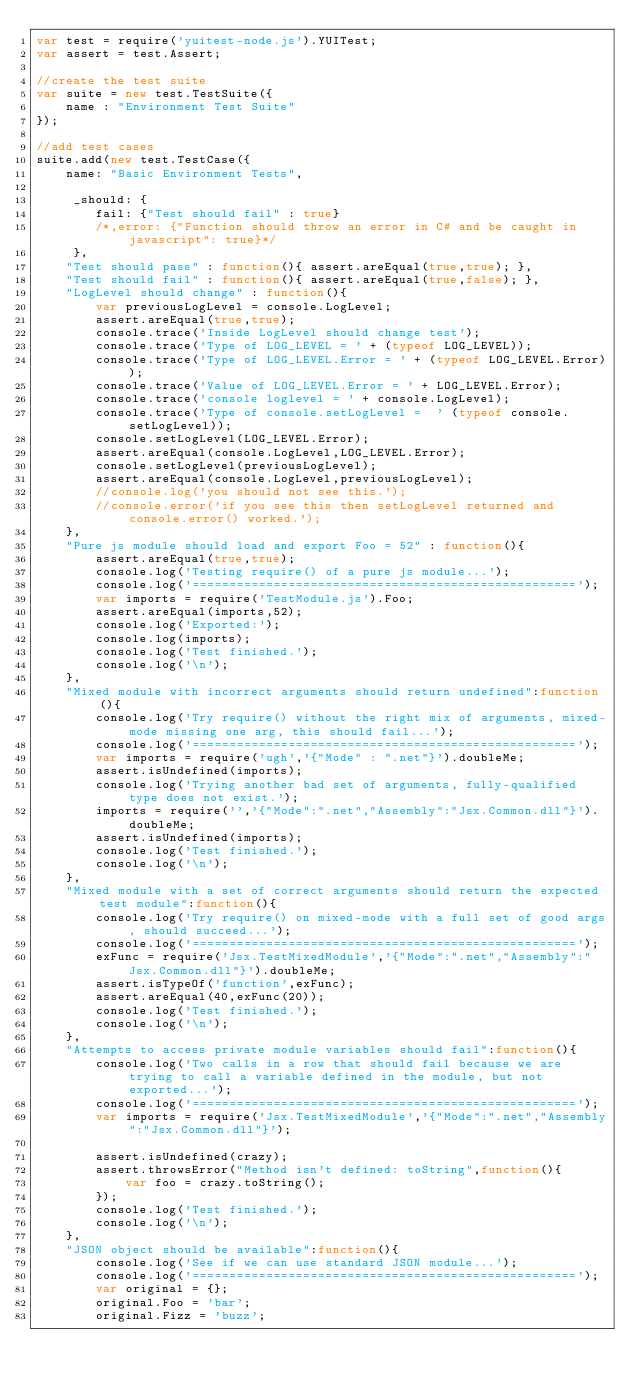<code> <loc_0><loc_0><loc_500><loc_500><_JavaScript_>var test = require('yuitest-node.js').YUITest;
var assert = test.Assert;

//create the test suite
var suite = new test.TestSuite({
	name : "Environment Test Suite"
});

//add test cases
suite.add(new test.TestCase({
    name: "Basic Environment Tests",
  
     _should: {
     	fail: {"Test should fail" : true}
     	/*,error: {"Function should throw an error in C# and be caught in javascript": true}*/
     },
    "Test should pass" : function(){ assert.areEqual(true,true); },
    "Test should fail" : function(){ assert.areEqual(true,false); },
    "LogLevel should change" : function(){ 
    	var previousLogLevel = console.LogLevel;
    	assert.areEqual(true,true);
    	console.trace('Inside LogLevel should change test');
    	console.trace('Type of LOG_LEVEL = ' + (typeof LOG_LEVEL));
    	console.trace('Type of LOG_LEVEL.Error = ' + (typeof LOG_LEVEL.Error));
    	console.trace('Value of LOG_LEVEL.Error = ' + LOG_LEVEL.Error);
    	console.trace('console loglevel = ' + console.LogLevel);
    	console.trace('Type of console.setLogLevel =  ' (typeof console.setLogLevel));
    	console.setLogLevel(LOG_LEVEL.Error);
    	assert.areEqual(console.LogLevel,LOG_LEVEL.Error);
    	console.setLogLevel(previousLogLevel);
    	assert.areEqual(console.LogLevel,previousLogLevel);
    	//console.log('you should not see this.');
    	//console.error('if you see this then setLogLevel returned and console.error() worked.');
    },
    "Pure js module should load and export Foo = 52" : function(){
    	assert.areEqual(true,true);
    	console.log('Testing require() of a pure js module...');
		console.log('====================================================');
    	var imports = require('TestModule.js').Foo;
    	assert.areEqual(imports,52);
		console.log('Exported:');
		console.log(imports);
		console.log('Test finished.');
		console.log('\n');
    },
    "Mixed module with incorrect arguments should return undefined":function(){
    	console.log('Try require() without the right mix of arguments, mixed-mode missing one arg, this should fail...');
		console.log('====================================================');
		var imports = require('ugh','{"Mode" : ".net"}').doubleMe;
		assert.isUndefined(imports);
		console.log('Trying another bad set of arguments, fully-qualified type does not exist.');
		imports = require('','{"Mode":".net","Assembly":"Jsx.Common.dll"}').doubleMe;
		assert.isUndefined(imports);
		console.log('Test finished.');
		console.log('\n');
    },
    "Mixed module with a set of correct arguments should return the expected test module":function(){
    	console.log('Try require() on mixed-mode with a full set of good args, should succeed...');
		console.log('====================================================');
		exFunc = require('Jsx.TestMixedModule','{"Mode":".net","Assembly":"Jsx.Common.dll"}').doubleMe;
		assert.isTypeOf('function',exFunc);
		assert.areEqual(40,exFunc(20));
		console.log('Test finished.');
		console.log('\n');
    },
    "Attempts to access private module variables should fail":function(){
    	console.log('Two calls in a row that should fail because we are trying to call a variable defined in the module, but not exported...');
    	console.log('====================================================');
		var imports = require('Jsx.TestMixedModule','{"Mode":".net","Assembly":"Jsx.Common.dll"}');
		
		assert.isUndefined(crazy);
		assert.throwsError("Method isn't defined: toString",function(){
			var foo = crazy.toString();
		});
		console.log('Test finished.');
		console.log('\n');
    },
    "JSON object should be available":function(){
    	console.log('See if we can use standard JSON module...');
		console.log('====================================================');
		var original = {};
		original.Foo = 'bar';
		original.Fizz = 'buzz';</code> 